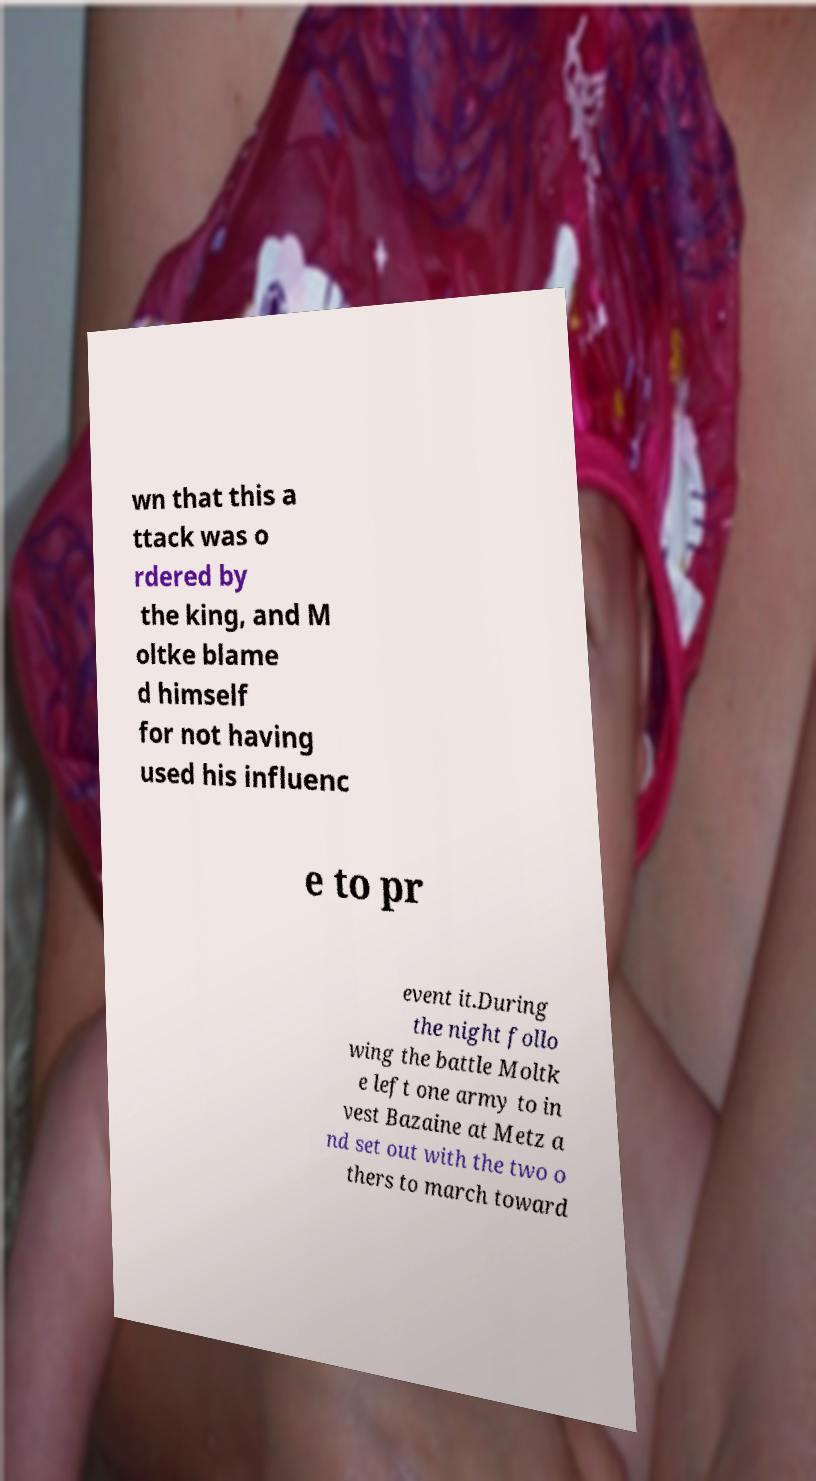There's text embedded in this image that I need extracted. Can you transcribe it verbatim? wn that this a ttack was o rdered by the king, and M oltke blame d himself for not having used his influenc e to pr event it.During the night follo wing the battle Moltk e left one army to in vest Bazaine at Metz a nd set out with the two o thers to march toward 